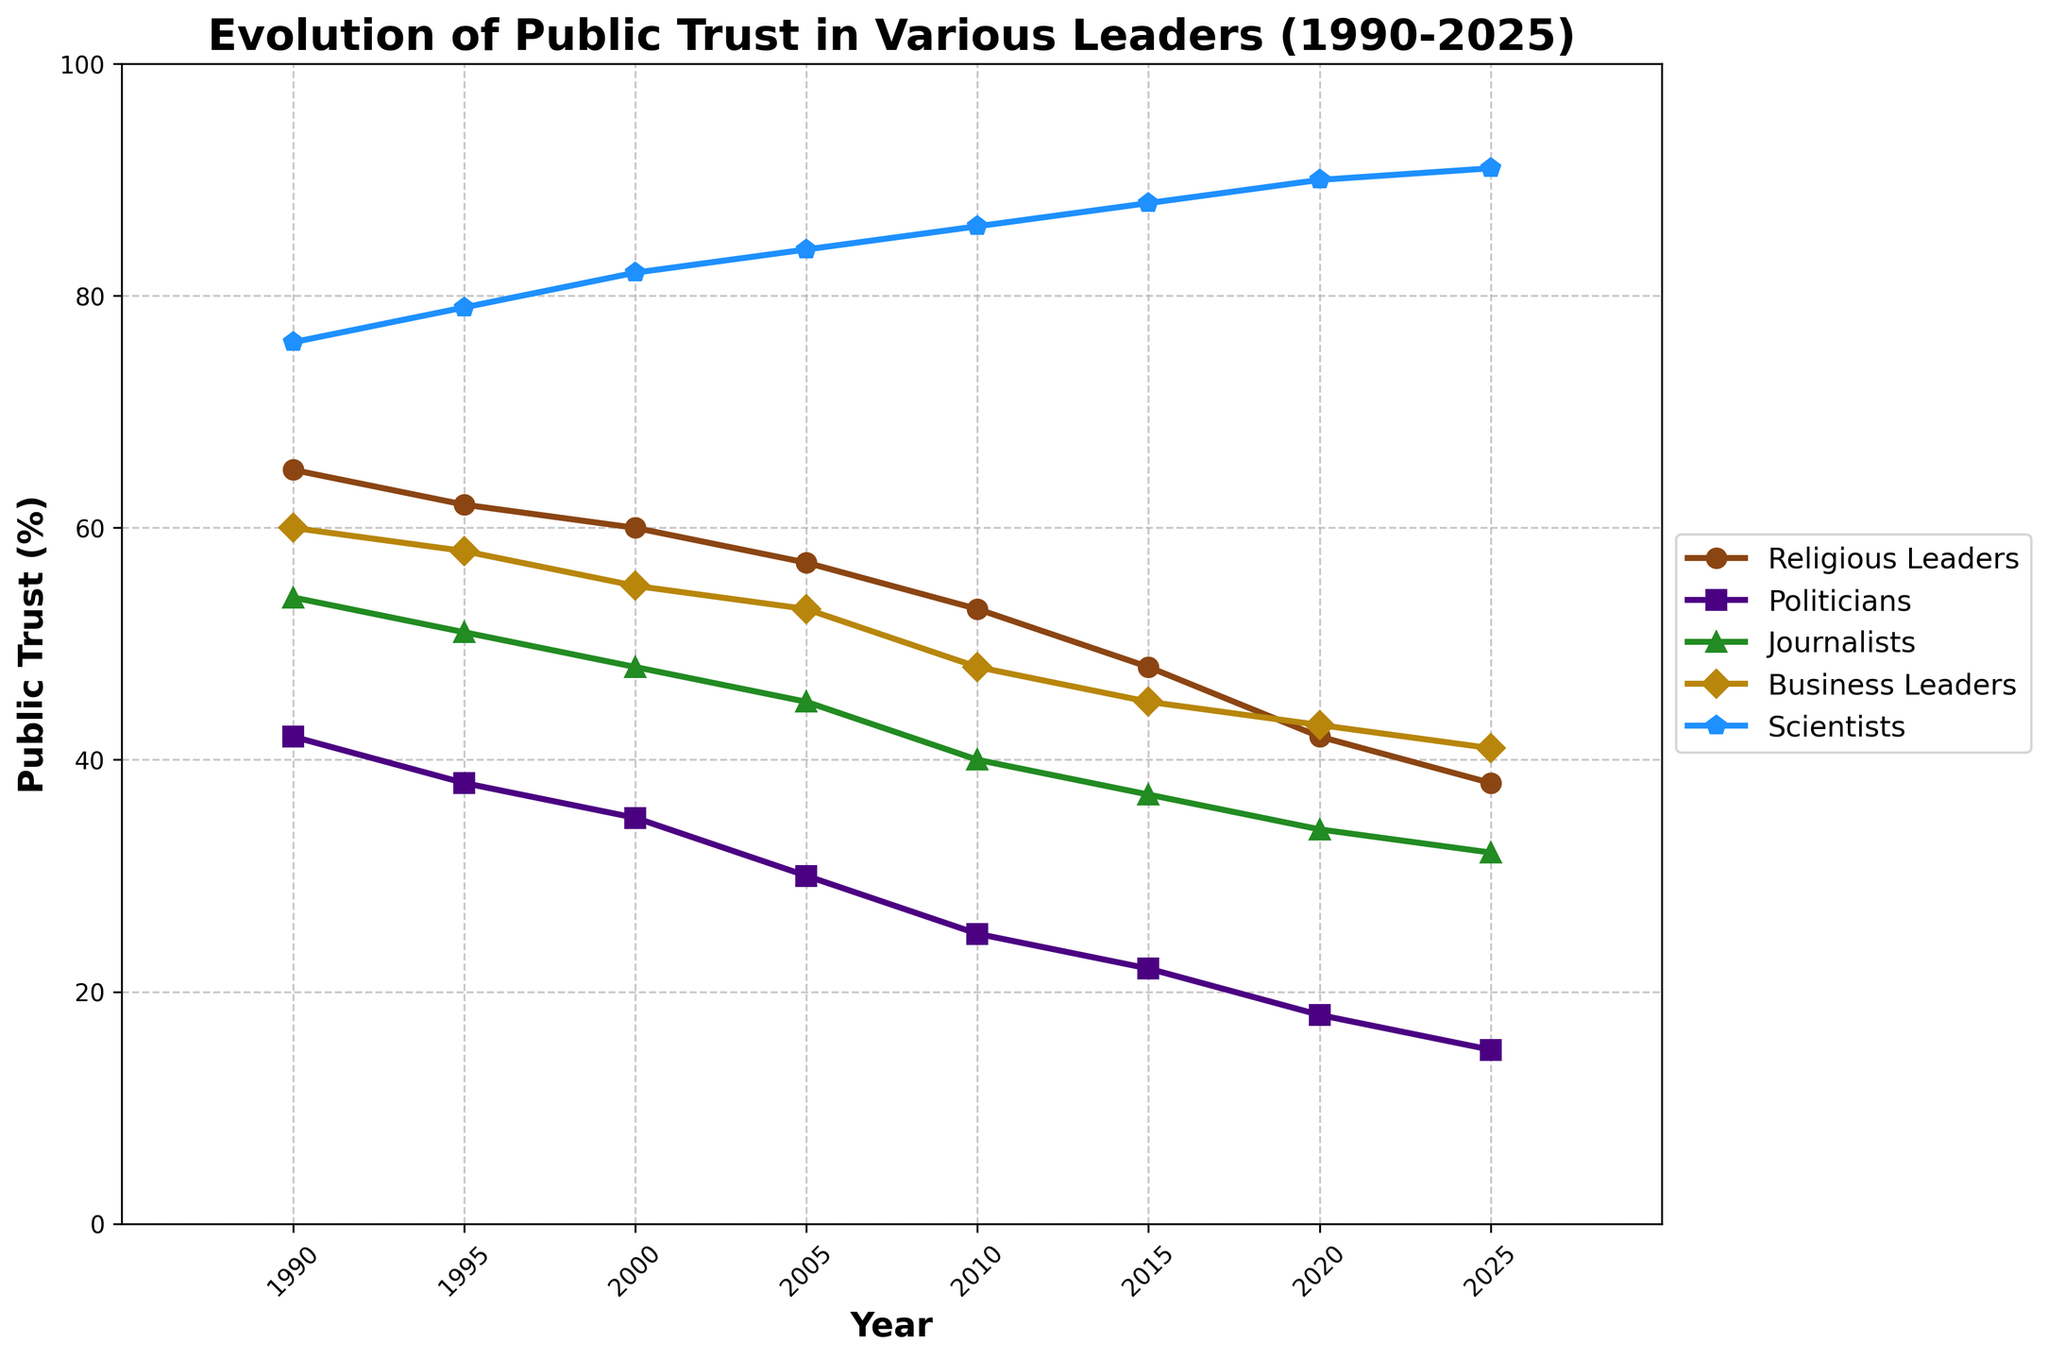What trend can be observed for the public trust in religious leaders from 1990 to 2025? The public trust in religious leaders shows a clear downward trend. Starting at 65% in 1990, it consistently decreases over the years, ending at 38% in 2025.
Answer: Downward trend In which year did religious leaders have the same level of public trust as business leaders? To find this, inspect the lines for religious leaders and business leaders and look for a year where the two intersect. This occurs in 2020 when both are at 42%.
Answer: 2020 What is the average public trust in scientists over all the years presented in the chart? Sum the values for scientists for all given years and divide by the number of years: (76 + 79 + 82 + 84 + 86 + 88 + 90 + 91) / 8. This is (676 / 8).
Answer: 84.5% Which group had the steepest decline in public trust from 1990 to 2025? The steepest decline can be observed by examining the vertical drop for each group. Politicians had the steepest decline, from 42% in 1990 to 15% in 2025, a drop of 27 points.
Answer: Politicians In 2025, how much higher is the public trust in scientists compared to politicians? In 2025, the trust in scientists is 91%, and the trust in politicians is 15%. The difference is 91% - 15%.
Answer: 76% Did journalists ever have higher public trust than business leaders? If yes, in which years? By comparing the values for journalists and business leaders over the years, journalists had more trust in 1990 (journalists 54%, business leaders 60%), and from 1995 onwards journalists always had less trust than business leaders. Hence there was no higher trust for journalists than business leaders in the years presented.
Answer: No Between which consecutive pairs of years did public trust in religious leaders see the largest decrease? Calculate the difference in trust levels for each consecutive pair of years and find the largest drop: from 1990 to 1995 (65% to 62%), from 1995 to 2000 (62% to 60%), and so on. The largest decrease is from 2015 to 2020, from 48% to 42%.
Answer: 2015 to 2020 Which group consistently had the highest public trust across all years? By examining the highest point in each year, it's clear that scientists always have the highest trust levels, consistently outperforming all other groups.
Answer: Scientists How did the public trust in politicians compare to religious leaders in 2000? In 2000, public trust in politicians was 35%, while for religious leaders it was 60%. Thus, public trust in religious leaders was significantly higher.
Answer: Higher for religious leaders What was the difference in public trust between the highest-trusted and lowest-trusted groups in 2025? In 2025, scientists had the highest trust at 91%, and politicians had the lowest at 15%. The difference is 91% - 15%.
Answer: 76% 